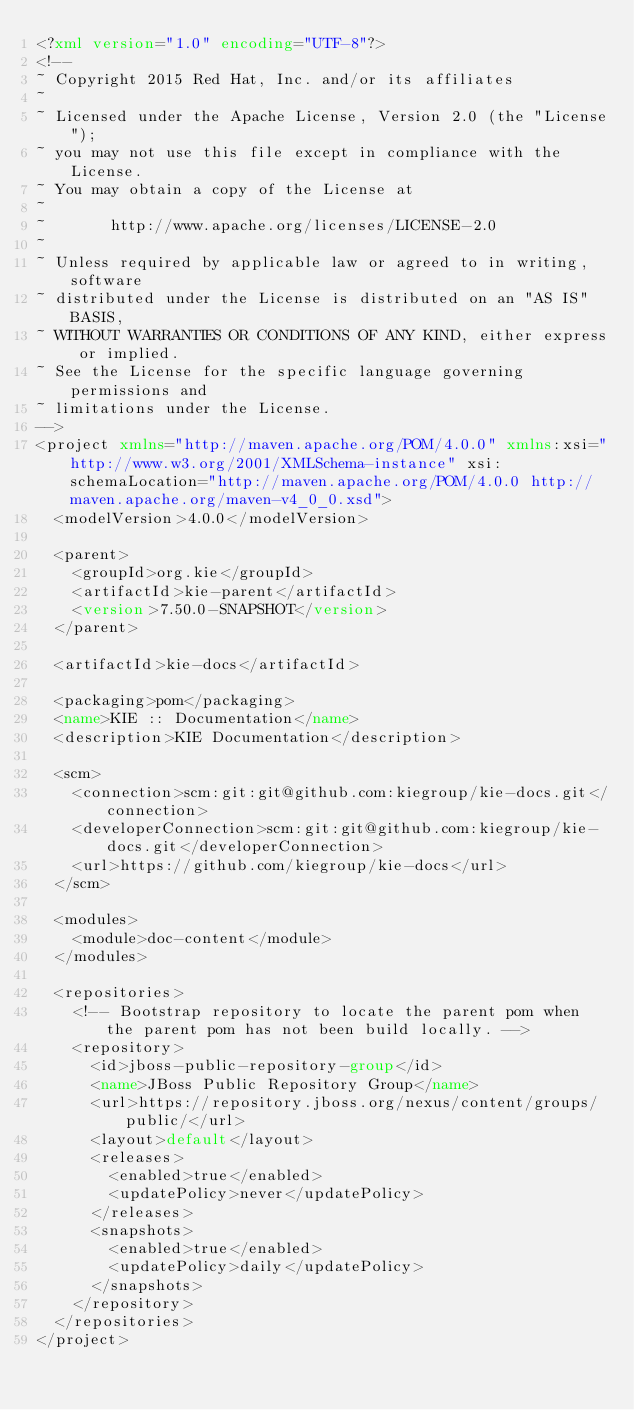<code> <loc_0><loc_0><loc_500><loc_500><_XML_><?xml version="1.0" encoding="UTF-8"?>
<!--
~ Copyright 2015 Red Hat, Inc. and/or its affiliates
~
~ Licensed under the Apache License, Version 2.0 (the "License");
~ you may not use this file except in compliance with the License.
~ You may obtain a copy of the License at
~
~       http://www.apache.org/licenses/LICENSE-2.0
~
~ Unless required by applicable law or agreed to in writing, software
~ distributed under the License is distributed on an "AS IS" BASIS,
~ WITHOUT WARRANTIES OR CONDITIONS OF ANY KIND, either express or implied.
~ See the License for the specific language governing permissions and
~ limitations under the License.
-->
<project xmlns="http://maven.apache.org/POM/4.0.0" xmlns:xsi="http://www.w3.org/2001/XMLSchema-instance" xsi:schemaLocation="http://maven.apache.org/POM/4.0.0 http://maven.apache.org/maven-v4_0_0.xsd">
  <modelVersion>4.0.0</modelVersion>

  <parent>
    <groupId>org.kie</groupId>
    <artifactId>kie-parent</artifactId>
    <version>7.50.0-SNAPSHOT</version>
  </parent>

  <artifactId>kie-docs</artifactId>

  <packaging>pom</packaging>
  <name>KIE :: Documentation</name>
  <description>KIE Documentation</description>

  <scm>
    <connection>scm:git:git@github.com:kiegroup/kie-docs.git</connection>
    <developerConnection>scm:git:git@github.com:kiegroup/kie-docs.git</developerConnection>
    <url>https://github.com/kiegroup/kie-docs</url>
  </scm>

  <modules>
    <module>doc-content</module>
  </modules>

  <repositories>
    <!-- Bootstrap repository to locate the parent pom when the parent pom has not been build locally. -->
    <repository>
      <id>jboss-public-repository-group</id>
      <name>JBoss Public Repository Group</name>
      <url>https://repository.jboss.org/nexus/content/groups/public/</url>
      <layout>default</layout>
      <releases>
        <enabled>true</enabled>
        <updatePolicy>never</updatePolicy>
      </releases>
      <snapshots>
        <enabled>true</enabled>
        <updatePolicy>daily</updatePolicy>
      </snapshots>
    </repository>
  </repositories>
</project>
</code> 